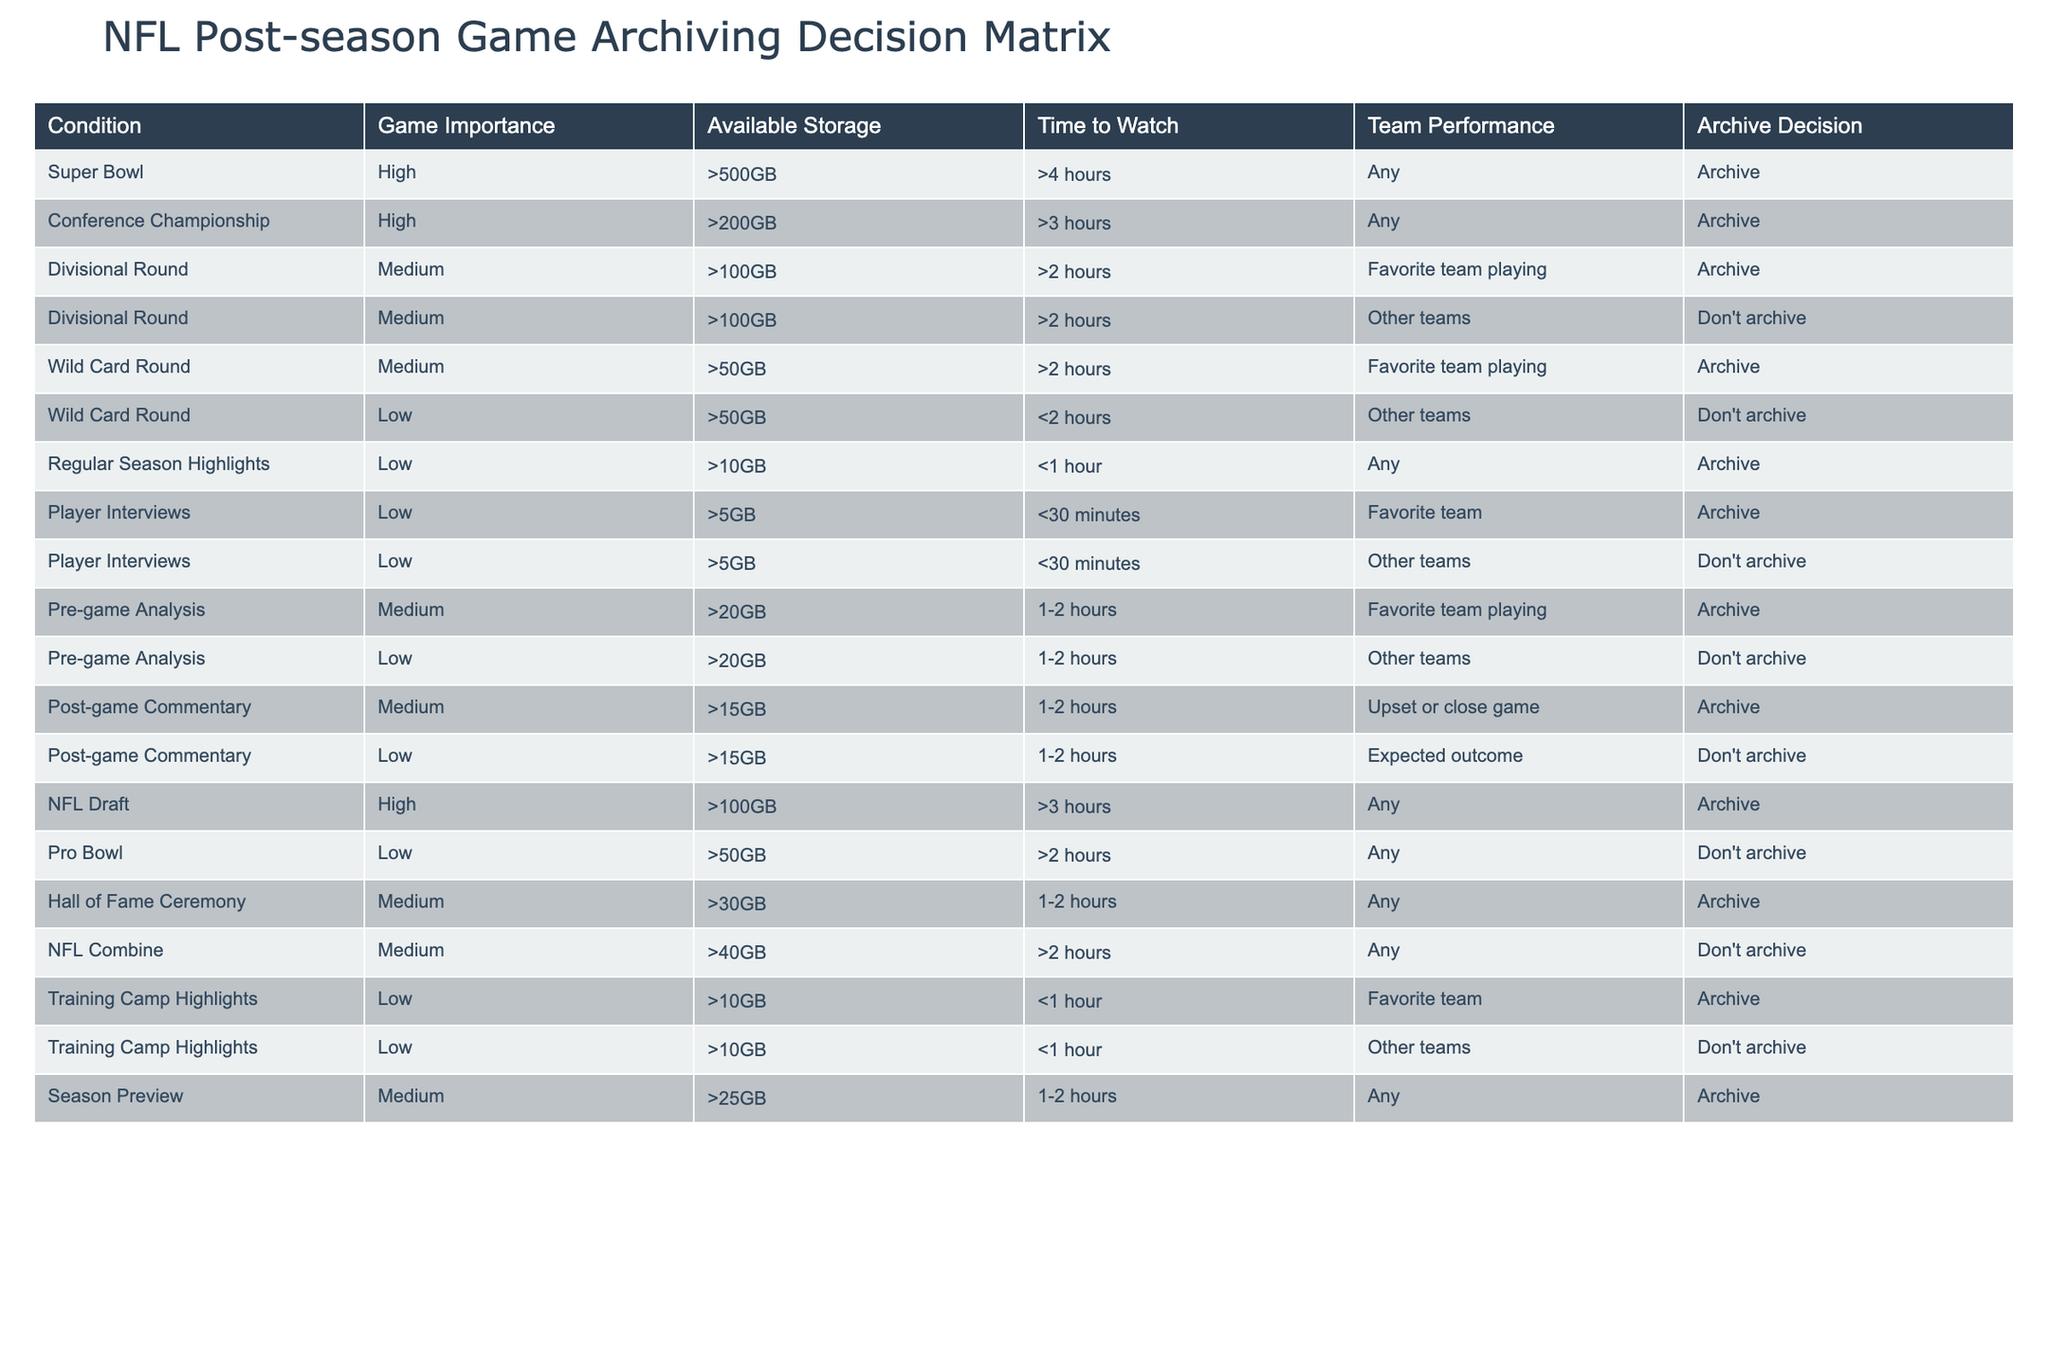What is the archive decision for the Super Bowl? The table indicates that for the Super Bowl, which has high game importance and more than 500GB of available storage, the decision is to archive.
Answer: Archive How many categories require archiving when the team performing is the favorite? By reviewing the rows where the "Team Performance" is marked as "Favorite team playing", there are five entries: Divisional Round, Wild Card Round, Pre-game Analysis, Player Interviews, and Training Camp Highlights. All these entries are categorized as "Archive".
Answer: Five Is the Hall of Fame Ceremony classified as a high or medium importance game? According to the table, the Hall of Fame Ceremony is categorized as medium importance.
Answer: Medium What is the total number of games classified as "Don't archive"? To find the games in the "Don't archive" category, we count the entries: Divisional Round (Other teams), Wild Card Round (Other teams), Post-game Commentary (Expected outcome), Pro Bowl, NFL Combine, and Training Camp Highlights (Other teams). This results in a total of six games.
Answer: Six Are Player Interviews archived regardless of which teams are featured? The table shows two entries for Player Interviews: one for the "Favorite team" which is archived, and one for "Other teams" which is not. Thus, the fact is false; Player Interviews are not archived for all teams.
Answer: No Which game type has the lowest storage requirement but is still archived, and what is its storage requirement? The Regular Season Highlights are archived despite having a low requirement of more than 10GB. This is the only entry listed with such a low requirement that is archived, confirming it as the lowest storage archived game type.
Answer: More than 10GB If a game is from the Wild Card Round but not featuring the favorite team, should it be archived? The table specifies that for Wild Card Round games featuring other teams, the decision is to not archive. Therefore, if the game does not involve the favorite team, it will not be archived.
Answer: No In the NFL Draft category, what is the time limit for viewing, and what is the archival decision? The NFL Draft category indicates a time requirement of more than 3 hours for any team performance; the archival decision is to archive, regardless of the team involved.
Answer: Archive, >3 hours 